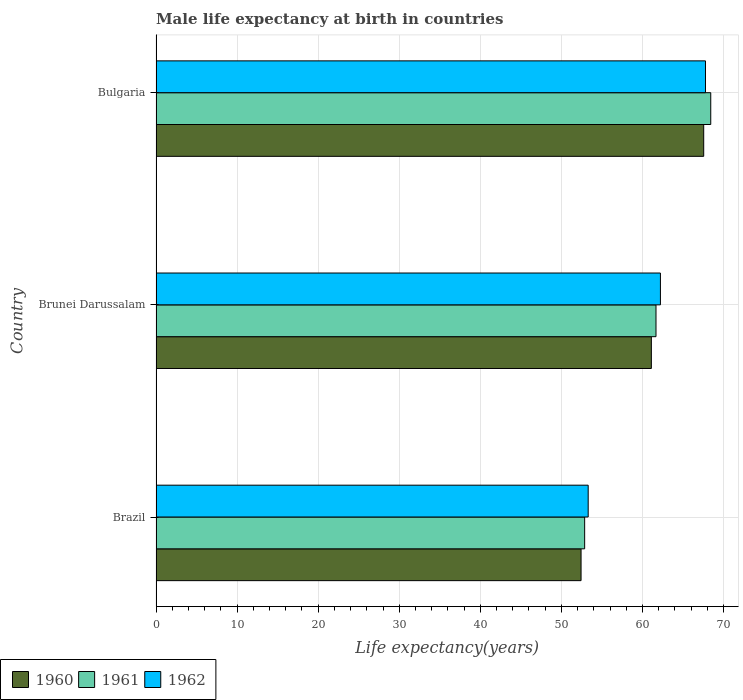How many groups of bars are there?
Your answer should be compact. 3. Are the number of bars per tick equal to the number of legend labels?
Give a very brief answer. Yes. How many bars are there on the 2nd tick from the top?
Give a very brief answer. 3. What is the label of the 2nd group of bars from the top?
Your response must be concise. Brunei Darussalam. What is the male life expectancy at birth in 1962 in Brazil?
Make the answer very short. 53.3. Across all countries, what is the maximum male life expectancy at birth in 1962?
Your response must be concise. 67.77. Across all countries, what is the minimum male life expectancy at birth in 1962?
Give a very brief answer. 53.3. In which country was the male life expectancy at birth in 1962 maximum?
Your answer should be very brief. Bulgaria. What is the total male life expectancy at birth in 1960 in the graph?
Provide a short and direct response. 181.07. What is the difference between the male life expectancy at birth in 1962 in Brazil and that in Brunei Darussalam?
Your answer should be very brief. -8.91. What is the difference between the male life expectancy at birth in 1960 in Brazil and the male life expectancy at birth in 1962 in Bulgaria?
Make the answer very short. -15.35. What is the average male life expectancy at birth in 1961 per country?
Ensure brevity in your answer.  60.98. What is the difference between the male life expectancy at birth in 1961 and male life expectancy at birth in 1960 in Bulgaria?
Provide a succinct answer. 0.87. In how many countries, is the male life expectancy at birth in 1962 greater than 54 years?
Your answer should be compact. 2. What is the ratio of the male life expectancy at birth in 1960 in Brazil to that in Brunei Darussalam?
Provide a succinct answer. 0.86. Is the difference between the male life expectancy at birth in 1961 in Brunei Darussalam and Bulgaria greater than the difference between the male life expectancy at birth in 1960 in Brunei Darussalam and Bulgaria?
Offer a very short reply. No. What is the difference between the highest and the second highest male life expectancy at birth in 1960?
Offer a very short reply. 6.45. What is the difference between the highest and the lowest male life expectancy at birth in 1961?
Keep it short and to the point. 15.55. In how many countries, is the male life expectancy at birth in 1960 greater than the average male life expectancy at birth in 1960 taken over all countries?
Your answer should be compact. 2. Is the sum of the male life expectancy at birth in 1962 in Brunei Darussalam and Bulgaria greater than the maximum male life expectancy at birth in 1961 across all countries?
Provide a short and direct response. Yes. How many countries are there in the graph?
Ensure brevity in your answer.  3. What is the difference between two consecutive major ticks on the X-axis?
Keep it short and to the point. 10. Are the values on the major ticks of X-axis written in scientific E-notation?
Offer a terse response. No. How many legend labels are there?
Keep it short and to the point. 3. How are the legend labels stacked?
Ensure brevity in your answer.  Horizontal. What is the title of the graph?
Give a very brief answer. Male life expectancy at birth in countries. Does "1997" appear as one of the legend labels in the graph?
Your answer should be very brief. No. What is the label or title of the X-axis?
Offer a very short reply. Life expectancy(years). What is the label or title of the Y-axis?
Offer a very short reply. Country. What is the Life expectancy(years) in 1960 in Brazil?
Make the answer very short. 52.42. What is the Life expectancy(years) in 1961 in Brazil?
Your answer should be very brief. 52.87. What is the Life expectancy(years) of 1962 in Brazil?
Provide a succinct answer. 53.3. What is the Life expectancy(years) in 1960 in Brunei Darussalam?
Offer a terse response. 61.09. What is the Life expectancy(years) in 1961 in Brunei Darussalam?
Give a very brief answer. 61.67. What is the Life expectancy(years) of 1962 in Brunei Darussalam?
Offer a terse response. 62.21. What is the Life expectancy(years) of 1960 in Bulgaria?
Make the answer very short. 67.55. What is the Life expectancy(years) of 1961 in Bulgaria?
Offer a terse response. 68.42. What is the Life expectancy(years) in 1962 in Bulgaria?
Provide a succinct answer. 67.77. Across all countries, what is the maximum Life expectancy(years) in 1960?
Ensure brevity in your answer.  67.55. Across all countries, what is the maximum Life expectancy(years) of 1961?
Provide a succinct answer. 68.42. Across all countries, what is the maximum Life expectancy(years) of 1962?
Give a very brief answer. 67.77. Across all countries, what is the minimum Life expectancy(years) of 1960?
Offer a very short reply. 52.42. Across all countries, what is the minimum Life expectancy(years) of 1961?
Your answer should be very brief. 52.87. Across all countries, what is the minimum Life expectancy(years) in 1962?
Ensure brevity in your answer.  53.3. What is the total Life expectancy(years) of 1960 in the graph?
Ensure brevity in your answer.  181.07. What is the total Life expectancy(years) of 1961 in the graph?
Your answer should be very brief. 182.95. What is the total Life expectancy(years) of 1962 in the graph?
Provide a succinct answer. 183.28. What is the difference between the Life expectancy(years) of 1960 in Brazil and that in Brunei Darussalam?
Provide a short and direct response. -8.67. What is the difference between the Life expectancy(years) of 1962 in Brazil and that in Brunei Darussalam?
Offer a terse response. -8.91. What is the difference between the Life expectancy(years) in 1960 in Brazil and that in Bulgaria?
Make the answer very short. -15.13. What is the difference between the Life expectancy(years) in 1961 in Brazil and that in Bulgaria?
Your response must be concise. -15.55. What is the difference between the Life expectancy(years) in 1962 in Brazil and that in Bulgaria?
Offer a terse response. -14.47. What is the difference between the Life expectancy(years) in 1960 in Brunei Darussalam and that in Bulgaria?
Offer a terse response. -6.46. What is the difference between the Life expectancy(years) of 1961 in Brunei Darussalam and that in Bulgaria?
Offer a very short reply. -6.75. What is the difference between the Life expectancy(years) of 1962 in Brunei Darussalam and that in Bulgaria?
Give a very brief answer. -5.56. What is the difference between the Life expectancy(years) in 1960 in Brazil and the Life expectancy(years) in 1961 in Brunei Darussalam?
Your response must be concise. -9.24. What is the difference between the Life expectancy(years) of 1960 in Brazil and the Life expectancy(years) of 1962 in Brunei Darussalam?
Ensure brevity in your answer.  -9.79. What is the difference between the Life expectancy(years) in 1961 in Brazil and the Life expectancy(years) in 1962 in Brunei Darussalam?
Provide a short and direct response. -9.35. What is the difference between the Life expectancy(years) of 1960 in Brazil and the Life expectancy(years) of 1961 in Bulgaria?
Give a very brief answer. -16. What is the difference between the Life expectancy(years) of 1960 in Brazil and the Life expectancy(years) of 1962 in Bulgaria?
Offer a terse response. -15.35. What is the difference between the Life expectancy(years) in 1961 in Brazil and the Life expectancy(years) in 1962 in Bulgaria?
Offer a terse response. -14.9. What is the difference between the Life expectancy(years) in 1960 in Brunei Darussalam and the Life expectancy(years) in 1961 in Bulgaria?
Provide a succinct answer. -7.33. What is the difference between the Life expectancy(years) of 1960 in Brunei Darussalam and the Life expectancy(years) of 1962 in Bulgaria?
Make the answer very short. -6.67. What is the difference between the Life expectancy(years) of 1961 in Brunei Darussalam and the Life expectancy(years) of 1962 in Bulgaria?
Offer a very short reply. -6.1. What is the average Life expectancy(years) in 1960 per country?
Ensure brevity in your answer.  60.36. What is the average Life expectancy(years) in 1961 per country?
Your answer should be compact. 60.98. What is the average Life expectancy(years) of 1962 per country?
Provide a short and direct response. 61.09. What is the difference between the Life expectancy(years) of 1960 and Life expectancy(years) of 1961 in Brazil?
Provide a short and direct response. -0.44. What is the difference between the Life expectancy(years) in 1960 and Life expectancy(years) in 1962 in Brazil?
Provide a short and direct response. -0.88. What is the difference between the Life expectancy(years) of 1961 and Life expectancy(years) of 1962 in Brazil?
Ensure brevity in your answer.  -0.43. What is the difference between the Life expectancy(years) of 1960 and Life expectancy(years) of 1961 in Brunei Darussalam?
Provide a short and direct response. -0.57. What is the difference between the Life expectancy(years) of 1960 and Life expectancy(years) of 1962 in Brunei Darussalam?
Ensure brevity in your answer.  -1.12. What is the difference between the Life expectancy(years) in 1961 and Life expectancy(years) in 1962 in Brunei Darussalam?
Make the answer very short. -0.55. What is the difference between the Life expectancy(years) in 1960 and Life expectancy(years) in 1961 in Bulgaria?
Provide a succinct answer. -0.87. What is the difference between the Life expectancy(years) in 1960 and Life expectancy(years) in 1962 in Bulgaria?
Make the answer very short. -0.22. What is the difference between the Life expectancy(years) of 1961 and Life expectancy(years) of 1962 in Bulgaria?
Offer a terse response. 0.65. What is the ratio of the Life expectancy(years) of 1960 in Brazil to that in Brunei Darussalam?
Your response must be concise. 0.86. What is the ratio of the Life expectancy(years) of 1961 in Brazil to that in Brunei Darussalam?
Your answer should be very brief. 0.86. What is the ratio of the Life expectancy(years) of 1962 in Brazil to that in Brunei Darussalam?
Give a very brief answer. 0.86. What is the ratio of the Life expectancy(years) in 1960 in Brazil to that in Bulgaria?
Make the answer very short. 0.78. What is the ratio of the Life expectancy(years) in 1961 in Brazil to that in Bulgaria?
Ensure brevity in your answer.  0.77. What is the ratio of the Life expectancy(years) in 1962 in Brazil to that in Bulgaria?
Your answer should be very brief. 0.79. What is the ratio of the Life expectancy(years) in 1960 in Brunei Darussalam to that in Bulgaria?
Ensure brevity in your answer.  0.9. What is the ratio of the Life expectancy(years) in 1961 in Brunei Darussalam to that in Bulgaria?
Provide a short and direct response. 0.9. What is the ratio of the Life expectancy(years) in 1962 in Brunei Darussalam to that in Bulgaria?
Provide a succinct answer. 0.92. What is the difference between the highest and the second highest Life expectancy(years) in 1960?
Make the answer very short. 6.46. What is the difference between the highest and the second highest Life expectancy(years) in 1961?
Offer a terse response. 6.75. What is the difference between the highest and the second highest Life expectancy(years) in 1962?
Give a very brief answer. 5.56. What is the difference between the highest and the lowest Life expectancy(years) of 1960?
Provide a succinct answer. 15.13. What is the difference between the highest and the lowest Life expectancy(years) in 1961?
Your answer should be compact. 15.55. What is the difference between the highest and the lowest Life expectancy(years) of 1962?
Keep it short and to the point. 14.47. 